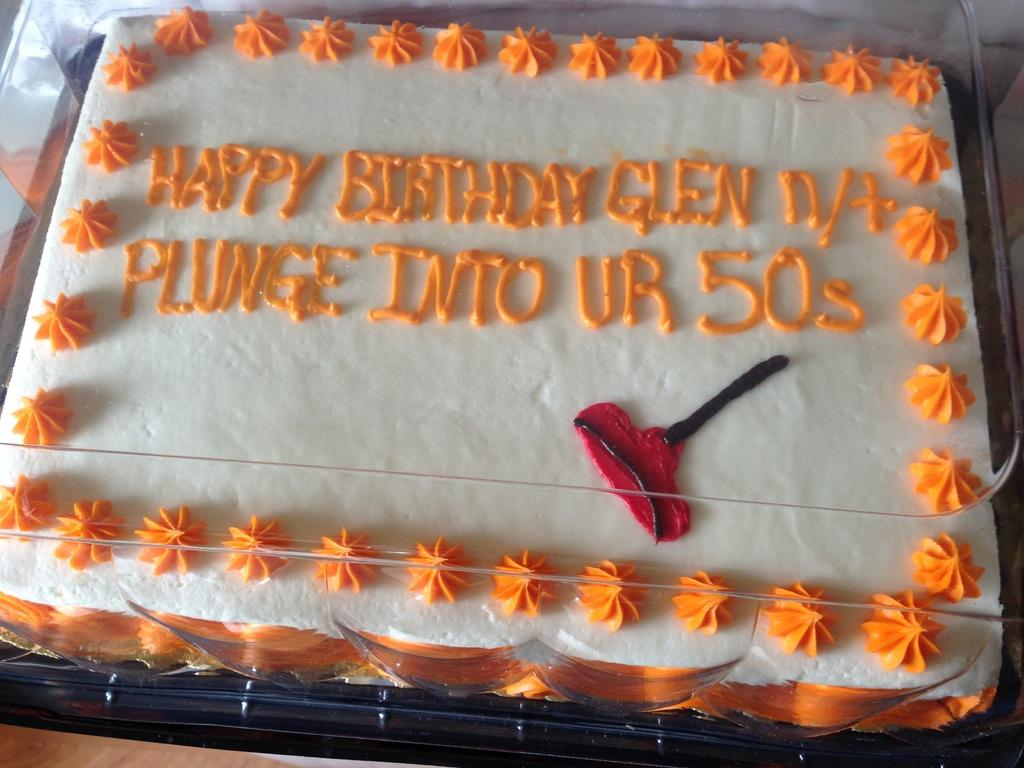What is the main subject of the image? There is a cake in the image. What can be seen on the cake? The cake has cream on it. How is the cake protected or covered? The cake is covered with a glass lid. What type of yak is depicted in the image? There is no yak present in the image; it features a cake with cream and a glass lid. What topics are being discussed by the cake in the image? Cakes do not have the ability to engage in discussions, so this question cannot be answered. 